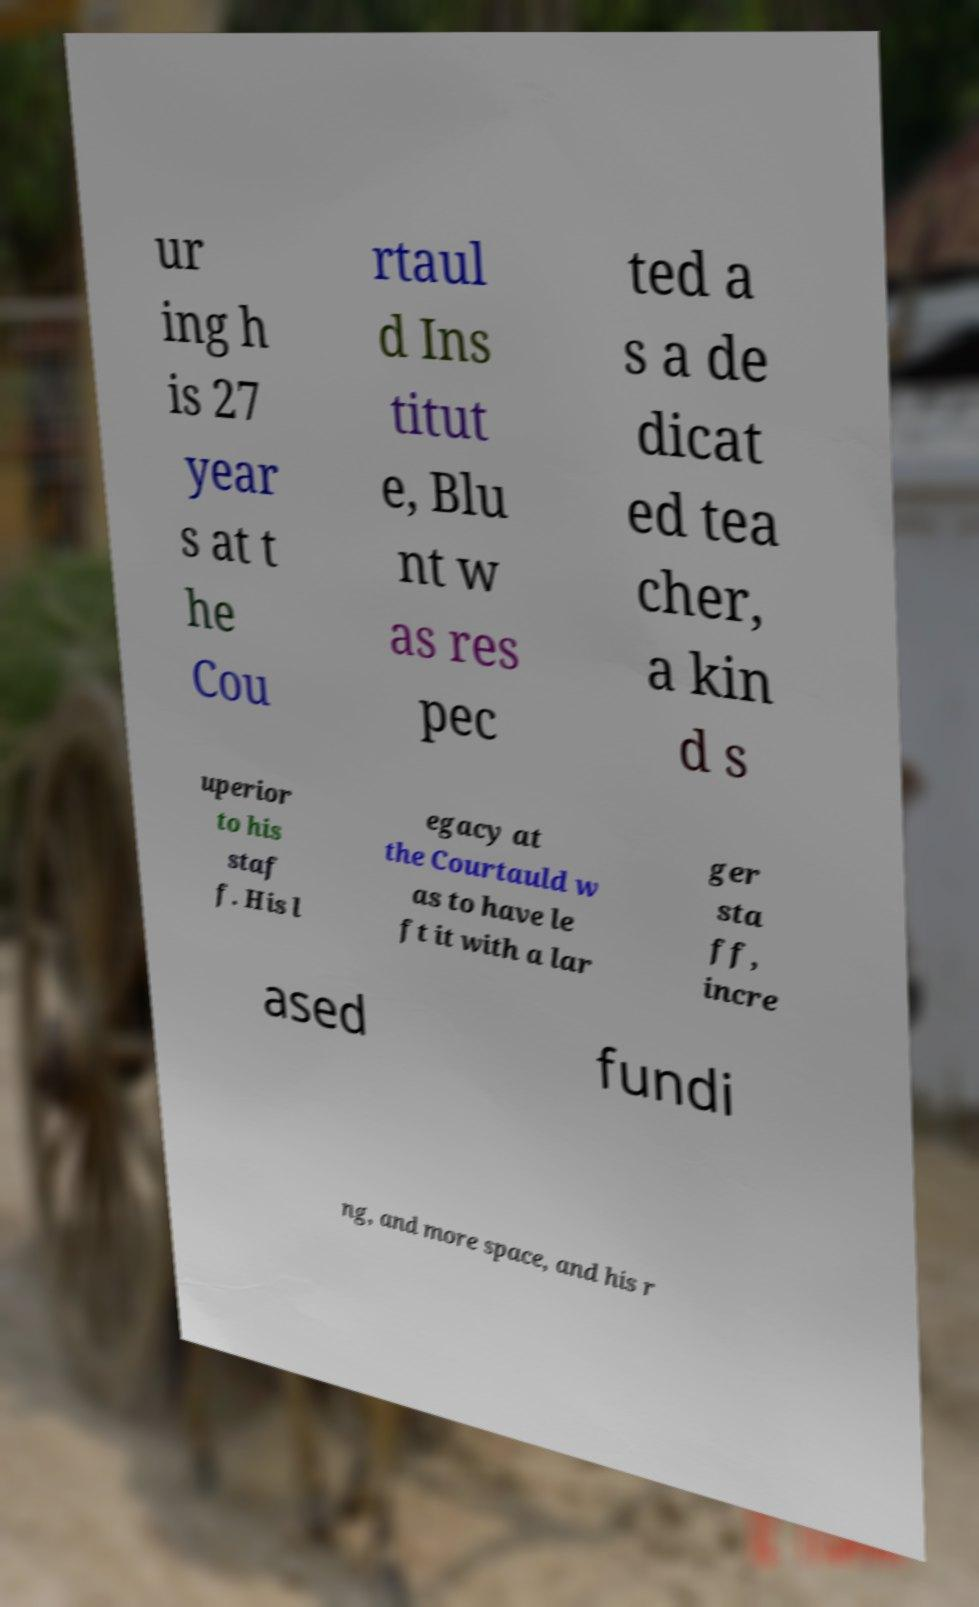For documentation purposes, I need the text within this image transcribed. Could you provide that? ur ing h is 27 year s at t he Cou rtaul d Ins titut e, Blu nt w as res pec ted a s a de dicat ed tea cher, a kin d s uperior to his staf f. His l egacy at the Courtauld w as to have le ft it with a lar ger sta ff, incre ased fundi ng, and more space, and his r 